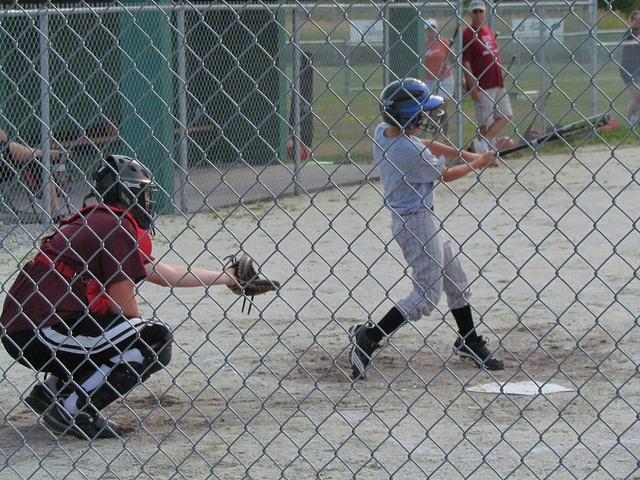Describe the objects in this image and their specific colors. I can see people in black, gray, darkgray, and maroon tones, people in black, gray, and darkgray tones, people in black, gray, maroon, and darkgray tones, people in black, gray, and darkgray tones, and people in black, gray, brown, and darkgray tones in this image. 